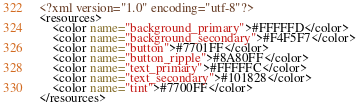Convert code to text. <code><loc_0><loc_0><loc_500><loc_500><_XML_><?xml version="1.0" encoding="utf-8"?>
<resources>
    <color name="background_primary">#FFFFFD</color>
    <color name="background_secondary">#F4F5F7</color>
    <color name="button">#7701FF</color>
    <color name="button_ripple">#8A80FF</color>
    <color name="text_primary">#FFFFFC</color>
    <color name="text_secondary">#101828</color>
    <color name="tint">#7700FF</color>
</resources></code> 